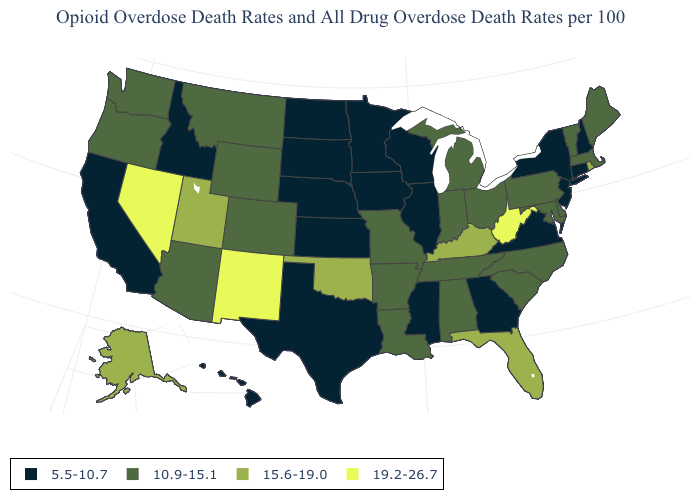What is the value of South Dakota?
Answer briefly. 5.5-10.7. How many symbols are there in the legend?
Answer briefly. 4. What is the highest value in states that border California?
Write a very short answer. 19.2-26.7. What is the value of Washington?
Be succinct. 10.9-15.1. Name the states that have a value in the range 15.6-19.0?
Give a very brief answer. Alaska, Florida, Kentucky, Oklahoma, Rhode Island, Utah. Does Minnesota have the lowest value in the USA?
Short answer required. Yes. What is the value of Arkansas?
Give a very brief answer. 10.9-15.1. Which states hav the highest value in the West?
Short answer required. Nevada, New Mexico. Which states have the lowest value in the South?
Concise answer only. Georgia, Mississippi, Texas, Virginia. Does New Mexico have the highest value in the USA?
Answer briefly. Yes. Among the states that border Arkansas , which have the lowest value?
Short answer required. Mississippi, Texas. What is the value of Massachusetts?
Be succinct. 10.9-15.1. Among the states that border Washington , which have the lowest value?
Quick response, please. Idaho. What is the highest value in states that border Massachusetts?
Short answer required. 15.6-19.0. What is the value of Virginia?
Give a very brief answer. 5.5-10.7. 